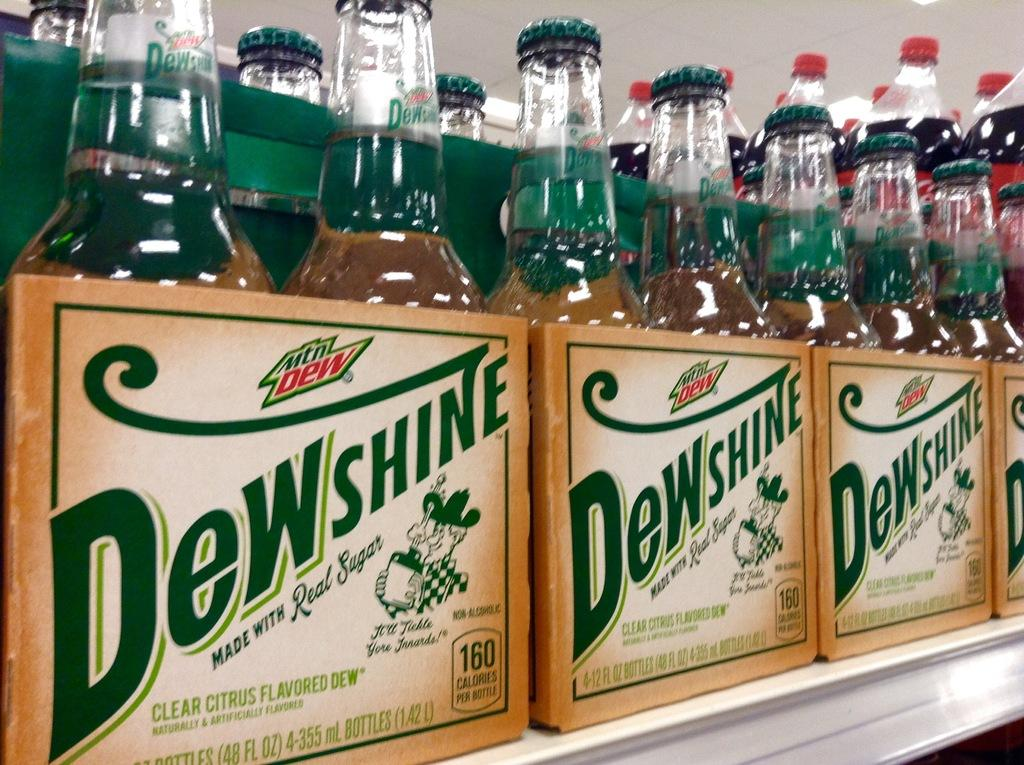<image>
Give a short and clear explanation of the subsequent image. Several cases with bottles of Dewshine sit on a shelf. 